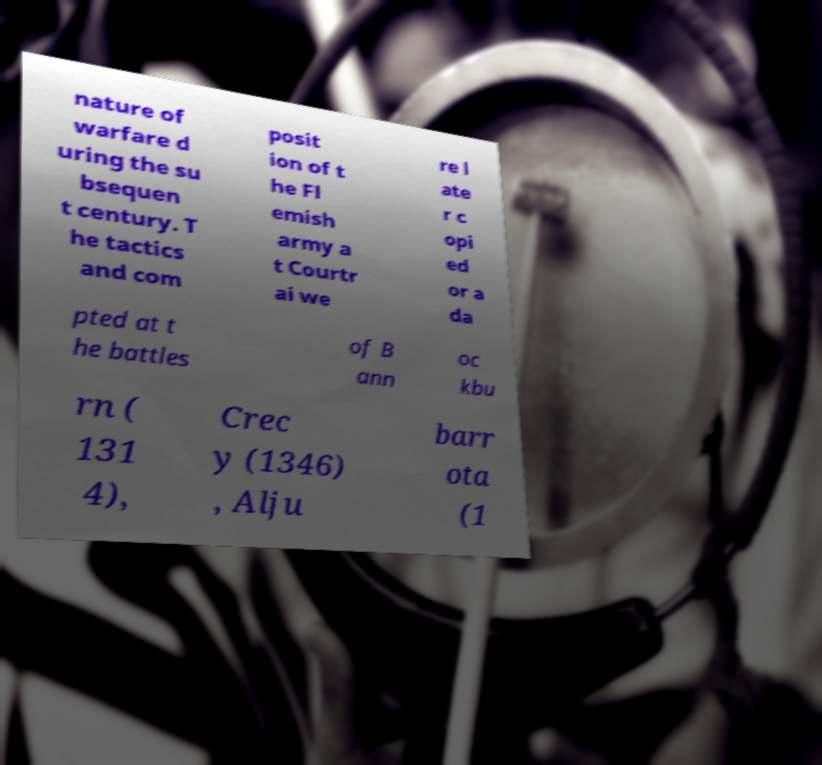For documentation purposes, I need the text within this image transcribed. Could you provide that? nature of warfare d uring the su bsequen t century. T he tactics and com posit ion of t he Fl emish army a t Courtr ai we re l ate r c opi ed or a da pted at t he battles of B ann oc kbu rn ( 131 4), Crec y (1346) , Alju barr ota (1 